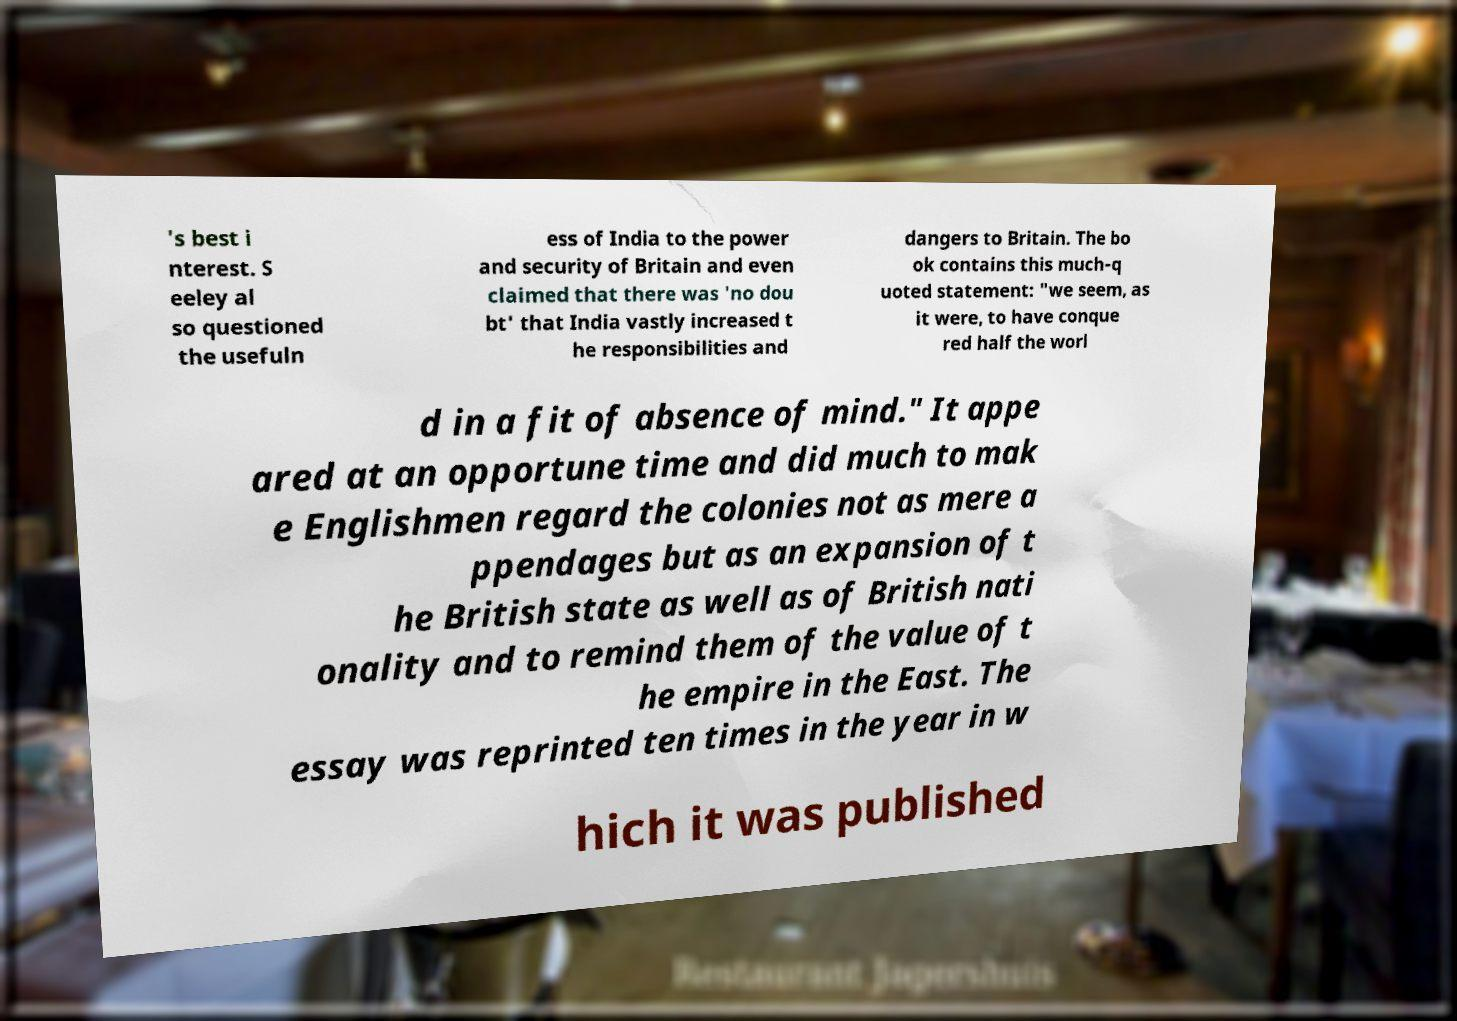Can you accurately transcribe the text from the provided image for me? 's best i nterest. S eeley al so questioned the usefuln ess of India to the power and security of Britain and even claimed that there was 'no dou bt' that India vastly increased t he responsibilities and dangers to Britain. The bo ok contains this much-q uoted statement: "we seem, as it were, to have conque red half the worl d in a fit of absence of mind." It appe ared at an opportune time and did much to mak e Englishmen regard the colonies not as mere a ppendages but as an expansion of t he British state as well as of British nati onality and to remind them of the value of t he empire in the East. The essay was reprinted ten times in the year in w hich it was published 